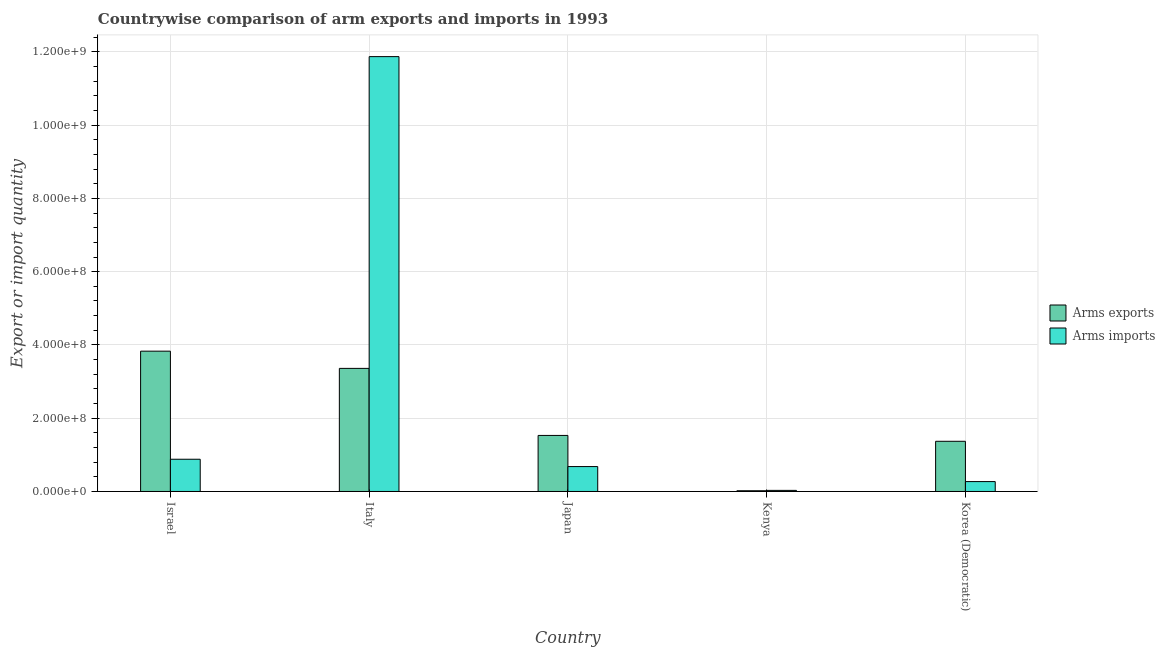How many groups of bars are there?
Offer a terse response. 5. How many bars are there on the 5th tick from the left?
Make the answer very short. 2. What is the label of the 5th group of bars from the left?
Offer a very short reply. Korea (Democratic). In how many cases, is the number of bars for a given country not equal to the number of legend labels?
Ensure brevity in your answer.  0. What is the arms exports in Kenya?
Your answer should be very brief. 2.00e+06. Across all countries, what is the maximum arms exports?
Keep it short and to the point. 3.83e+08. Across all countries, what is the minimum arms imports?
Make the answer very short. 3.00e+06. In which country was the arms imports minimum?
Provide a succinct answer. Kenya. What is the total arms imports in the graph?
Keep it short and to the point. 1.37e+09. What is the difference between the arms imports in Italy and that in Japan?
Your answer should be very brief. 1.12e+09. What is the difference between the arms exports in Korea (Democratic) and the arms imports in Japan?
Your response must be concise. 6.90e+07. What is the average arms exports per country?
Provide a succinct answer. 2.02e+08. What is the difference between the arms imports and arms exports in Kenya?
Offer a terse response. 1.00e+06. What is the ratio of the arms imports in Italy to that in Kenya?
Ensure brevity in your answer.  395.67. Is the arms exports in Israel less than that in Japan?
Your answer should be compact. No. Is the difference between the arms exports in Italy and Korea (Democratic) greater than the difference between the arms imports in Italy and Korea (Democratic)?
Your response must be concise. No. What is the difference between the highest and the second highest arms exports?
Offer a terse response. 4.70e+07. What is the difference between the highest and the lowest arms imports?
Make the answer very short. 1.18e+09. In how many countries, is the arms imports greater than the average arms imports taken over all countries?
Ensure brevity in your answer.  1. Is the sum of the arms imports in Japan and Kenya greater than the maximum arms exports across all countries?
Provide a short and direct response. No. What does the 1st bar from the left in Israel represents?
Your answer should be compact. Arms exports. What does the 2nd bar from the right in Japan represents?
Offer a terse response. Arms exports. Are all the bars in the graph horizontal?
Provide a succinct answer. No. What is the difference between two consecutive major ticks on the Y-axis?
Your answer should be compact. 2.00e+08. Are the values on the major ticks of Y-axis written in scientific E-notation?
Offer a very short reply. Yes. Where does the legend appear in the graph?
Your answer should be compact. Center right. How many legend labels are there?
Provide a short and direct response. 2. What is the title of the graph?
Provide a succinct answer. Countrywise comparison of arm exports and imports in 1993. What is the label or title of the Y-axis?
Make the answer very short. Export or import quantity. What is the Export or import quantity in Arms exports in Israel?
Provide a short and direct response. 3.83e+08. What is the Export or import quantity in Arms imports in Israel?
Ensure brevity in your answer.  8.80e+07. What is the Export or import quantity of Arms exports in Italy?
Keep it short and to the point. 3.36e+08. What is the Export or import quantity of Arms imports in Italy?
Your answer should be compact. 1.19e+09. What is the Export or import quantity in Arms exports in Japan?
Make the answer very short. 1.53e+08. What is the Export or import quantity of Arms imports in Japan?
Your response must be concise. 6.80e+07. What is the Export or import quantity in Arms exports in Korea (Democratic)?
Provide a short and direct response. 1.37e+08. What is the Export or import quantity in Arms imports in Korea (Democratic)?
Your answer should be compact. 2.70e+07. Across all countries, what is the maximum Export or import quantity of Arms exports?
Ensure brevity in your answer.  3.83e+08. Across all countries, what is the maximum Export or import quantity in Arms imports?
Offer a very short reply. 1.19e+09. Across all countries, what is the minimum Export or import quantity in Arms imports?
Your response must be concise. 3.00e+06. What is the total Export or import quantity of Arms exports in the graph?
Make the answer very short. 1.01e+09. What is the total Export or import quantity of Arms imports in the graph?
Keep it short and to the point. 1.37e+09. What is the difference between the Export or import quantity in Arms exports in Israel and that in Italy?
Offer a very short reply. 4.70e+07. What is the difference between the Export or import quantity in Arms imports in Israel and that in Italy?
Offer a terse response. -1.10e+09. What is the difference between the Export or import quantity in Arms exports in Israel and that in Japan?
Offer a very short reply. 2.30e+08. What is the difference between the Export or import quantity in Arms imports in Israel and that in Japan?
Your response must be concise. 2.00e+07. What is the difference between the Export or import quantity in Arms exports in Israel and that in Kenya?
Make the answer very short. 3.81e+08. What is the difference between the Export or import quantity in Arms imports in Israel and that in Kenya?
Your answer should be very brief. 8.50e+07. What is the difference between the Export or import quantity of Arms exports in Israel and that in Korea (Democratic)?
Offer a terse response. 2.46e+08. What is the difference between the Export or import quantity of Arms imports in Israel and that in Korea (Democratic)?
Provide a succinct answer. 6.10e+07. What is the difference between the Export or import quantity in Arms exports in Italy and that in Japan?
Your answer should be compact. 1.83e+08. What is the difference between the Export or import quantity in Arms imports in Italy and that in Japan?
Offer a terse response. 1.12e+09. What is the difference between the Export or import quantity in Arms exports in Italy and that in Kenya?
Give a very brief answer. 3.34e+08. What is the difference between the Export or import quantity of Arms imports in Italy and that in Kenya?
Offer a terse response. 1.18e+09. What is the difference between the Export or import quantity of Arms exports in Italy and that in Korea (Democratic)?
Make the answer very short. 1.99e+08. What is the difference between the Export or import quantity in Arms imports in Italy and that in Korea (Democratic)?
Keep it short and to the point. 1.16e+09. What is the difference between the Export or import quantity in Arms exports in Japan and that in Kenya?
Your answer should be compact. 1.51e+08. What is the difference between the Export or import quantity in Arms imports in Japan and that in Kenya?
Provide a short and direct response. 6.50e+07. What is the difference between the Export or import quantity of Arms exports in Japan and that in Korea (Democratic)?
Offer a very short reply. 1.60e+07. What is the difference between the Export or import quantity of Arms imports in Japan and that in Korea (Democratic)?
Your answer should be very brief. 4.10e+07. What is the difference between the Export or import quantity in Arms exports in Kenya and that in Korea (Democratic)?
Ensure brevity in your answer.  -1.35e+08. What is the difference between the Export or import quantity of Arms imports in Kenya and that in Korea (Democratic)?
Your answer should be very brief. -2.40e+07. What is the difference between the Export or import quantity in Arms exports in Israel and the Export or import quantity in Arms imports in Italy?
Ensure brevity in your answer.  -8.04e+08. What is the difference between the Export or import quantity in Arms exports in Israel and the Export or import quantity in Arms imports in Japan?
Make the answer very short. 3.15e+08. What is the difference between the Export or import quantity in Arms exports in Israel and the Export or import quantity in Arms imports in Kenya?
Provide a short and direct response. 3.80e+08. What is the difference between the Export or import quantity in Arms exports in Israel and the Export or import quantity in Arms imports in Korea (Democratic)?
Ensure brevity in your answer.  3.56e+08. What is the difference between the Export or import quantity of Arms exports in Italy and the Export or import quantity of Arms imports in Japan?
Provide a short and direct response. 2.68e+08. What is the difference between the Export or import quantity of Arms exports in Italy and the Export or import quantity of Arms imports in Kenya?
Keep it short and to the point. 3.33e+08. What is the difference between the Export or import quantity of Arms exports in Italy and the Export or import quantity of Arms imports in Korea (Democratic)?
Offer a very short reply. 3.09e+08. What is the difference between the Export or import quantity in Arms exports in Japan and the Export or import quantity in Arms imports in Kenya?
Make the answer very short. 1.50e+08. What is the difference between the Export or import quantity in Arms exports in Japan and the Export or import quantity in Arms imports in Korea (Democratic)?
Ensure brevity in your answer.  1.26e+08. What is the difference between the Export or import quantity in Arms exports in Kenya and the Export or import quantity in Arms imports in Korea (Democratic)?
Give a very brief answer. -2.50e+07. What is the average Export or import quantity in Arms exports per country?
Offer a terse response. 2.02e+08. What is the average Export or import quantity in Arms imports per country?
Keep it short and to the point. 2.75e+08. What is the difference between the Export or import quantity of Arms exports and Export or import quantity of Arms imports in Israel?
Give a very brief answer. 2.95e+08. What is the difference between the Export or import quantity of Arms exports and Export or import quantity of Arms imports in Italy?
Make the answer very short. -8.51e+08. What is the difference between the Export or import quantity of Arms exports and Export or import quantity of Arms imports in Japan?
Provide a short and direct response. 8.50e+07. What is the difference between the Export or import quantity of Arms exports and Export or import quantity of Arms imports in Kenya?
Ensure brevity in your answer.  -1.00e+06. What is the difference between the Export or import quantity in Arms exports and Export or import quantity in Arms imports in Korea (Democratic)?
Your response must be concise. 1.10e+08. What is the ratio of the Export or import quantity in Arms exports in Israel to that in Italy?
Your answer should be compact. 1.14. What is the ratio of the Export or import quantity of Arms imports in Israel to that in Italy?
Ensure brevity in your answer.  0.07. What is the ratio of the Export or import quantity of Arms exports in Israel to that in Japan?
Provide a succinct answer. 2.5. What is the ratio of the Export or import quantity in Arms imports in Israel to that in Japan?
Provide a succinct answer. 1.29. What is the ratio of the Export or import quantity in Arms exports in Israel to that in Kenya?
Give a very brief answer. 191.5. What is the ratio of the Export or import quantity of Arms imports in Israel to that in Kenya?
Give a very brief answer. 29.33. What is the ratio of the Export or import quantity of Arms exports in Israel to that in Korea (Democratic)?
Keep it short and to the point. 2.8. What is the ratio of the Export or import quantity in Arms imports in Israel to that in Korea (Democratic)?
Offer a very short reply. 3.26. What is the ratio of the Export or import quantity of Arms exports in Italy to that in Japan?
Keep it short and to the point. 2.2. What is the ratio of the Export or import quantity in Arms imports in Italy to that in Japan?
Offer a terse response. 17.46. What is the ratio of the Export or import quantity of Arms exports in Italy to that in Kenya?
Keep it short and to the point. 168. What is the ratio of the Export or import quantity of Arms imports in Italy to that in Kenya?
Offer a very short reply. 395.67. What is the ratio of the Export or import quantity in Arms exports in Italy to that in Korea (Democratic)?
Offer a very short reply. 2.45. What is the ratio of the Export or import quantity of Arms imports in Italy to that in Korea (Democratic)?
Your answer should be very brief. 43.96. What is the ratio of the Export or import quantity of Arms exports in Japan to that in Kenya?
Ensure brevity in your answer.  76.5. What is the ratio of the Export or import quantity in Arms imports in Japan to that in Kenya?
Give a very brief answer. 22.67. What is the ratio of the Export or import quantity of Arms exports in Japan to that in Korea (Democratic)?
Provide a short and direct response. 1.12. What is the ratio of the Export or import quantity of Arms imports in Japan to that in Korea (Democratic)?
Keep it short and to the point. 2.52. What is the ratio of the Export or import quantity in Arms exports in Kenya to that in Korea (Democratic)?
Provide a short and direct response. 0.01. What is the difference between the highest and the second highest Export or import quantity of Arms exports?
Offer a very short reply. 4.70e+07. What is the difference between the highest and the second highest Export or import quantity in Arms imports?
Offer a very short reply. 1.10e+09. What is the difference between the highest and the lowest Export or import quantity in Arms exports?
Give a very brief answer. 3.81e+08. What is the difference between the highest and the lowest Export or import quantity in Arms imports?
Offer a terse response. 1.18e+09. 